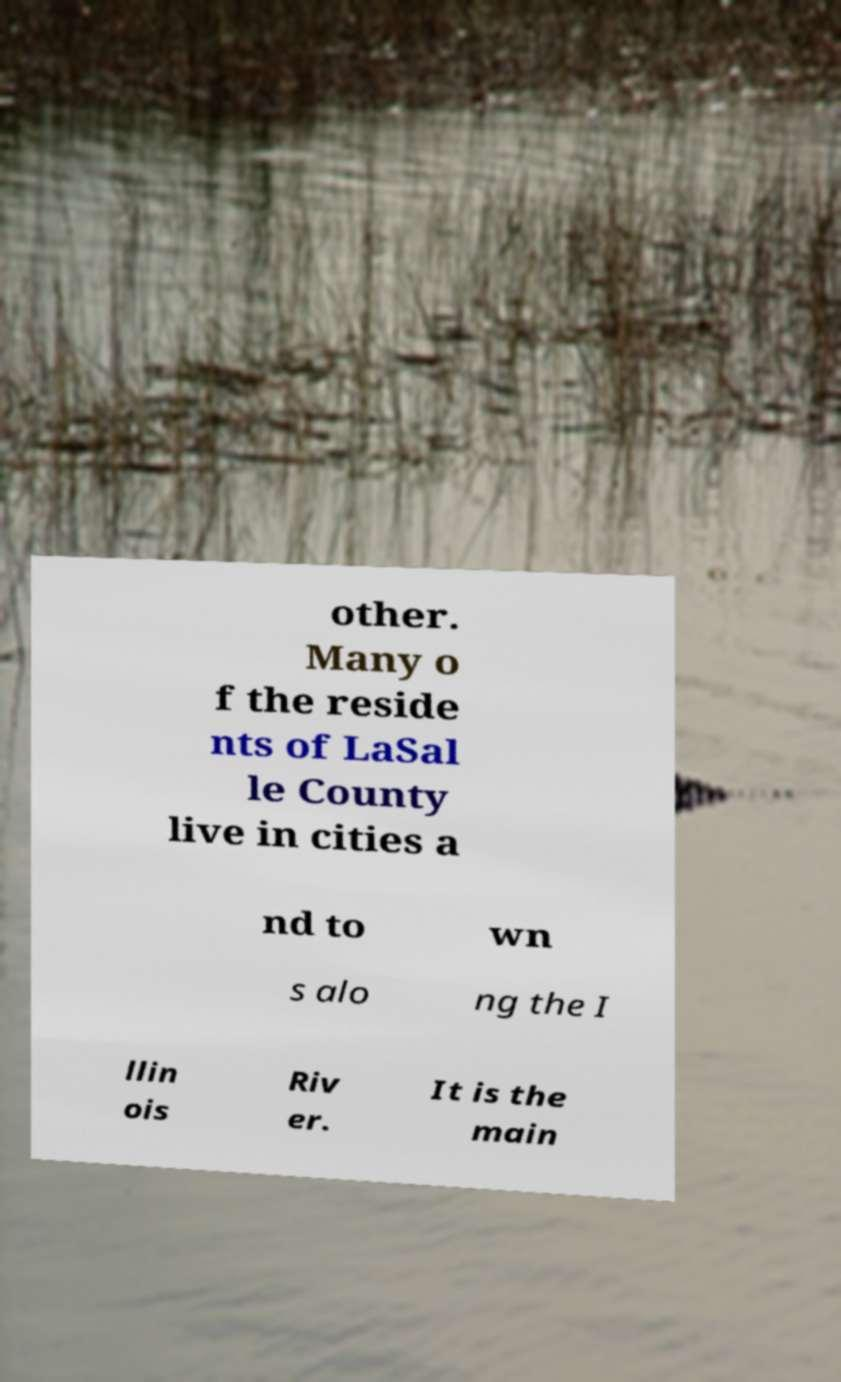I need the written content from this picture converted into text. Can you do that? other. Many o f the reside nts of LaSal le County live in cities a nd to wn s alo ng the I llin ois Riv er. It is the main 